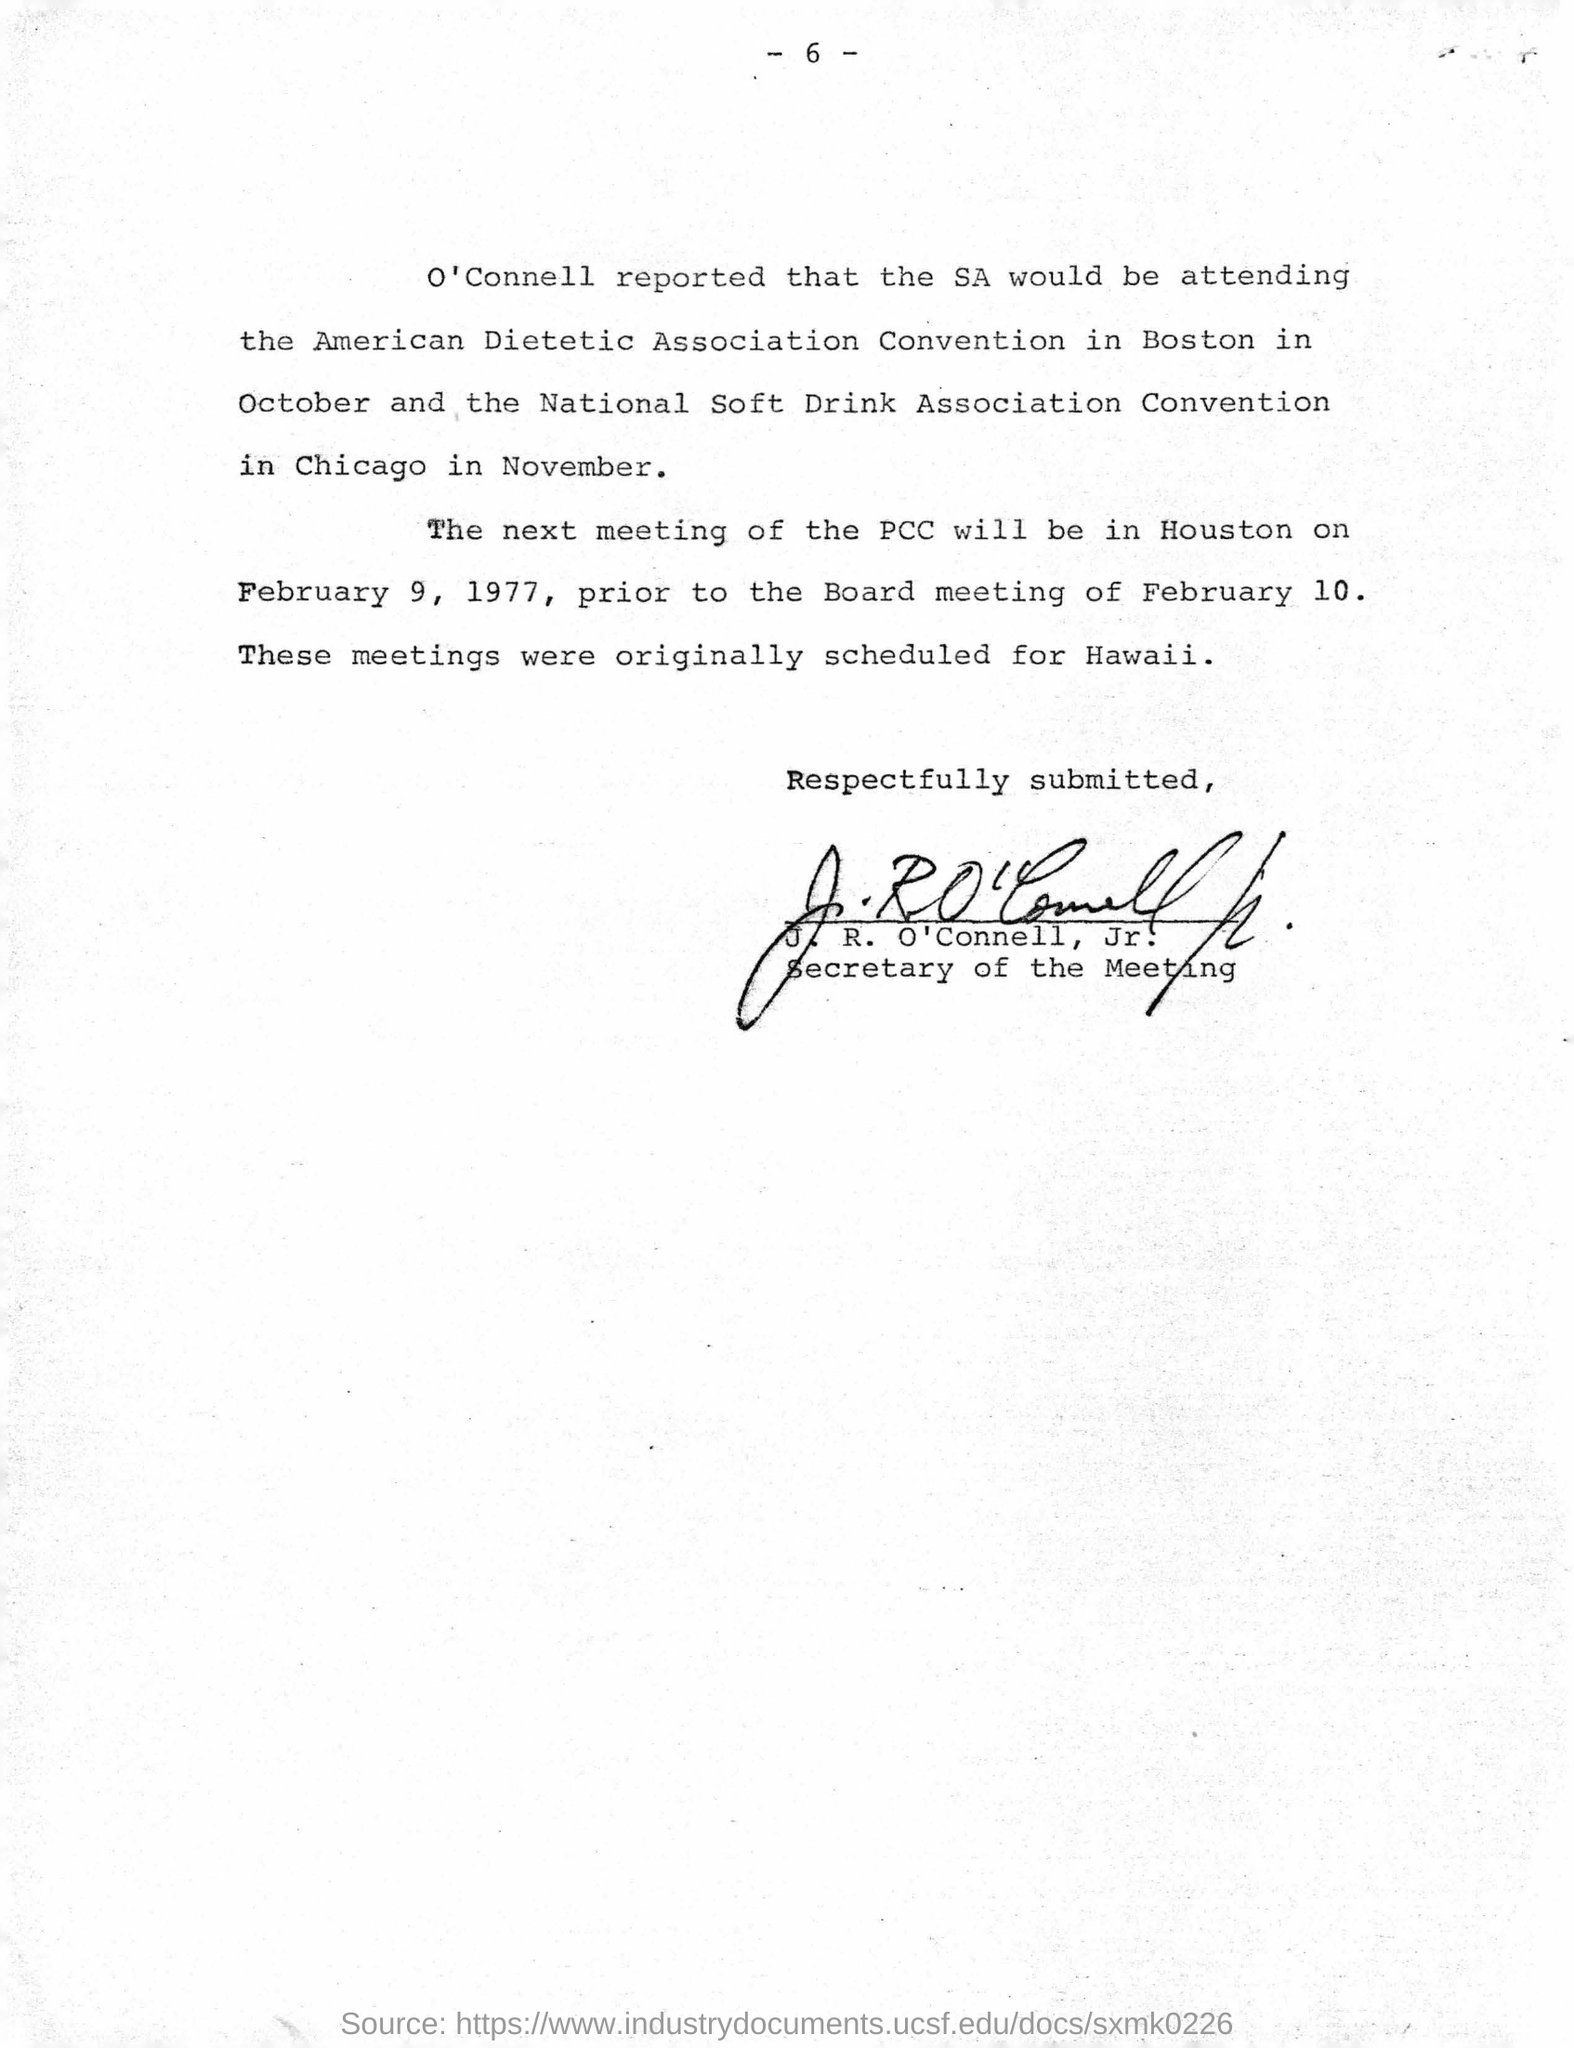List a handful of essential elements in this visual. The next meeting of the PCC was held on February 9, 1977. It was reported by O'Connell that SA would be attending the Convention. The document was signed by J. R. O'Connell, Jr. The individual known as J. R. O'Connell is designated as the Secretary of the Meeting. The meetings were originally scheduled for Hawaii. 